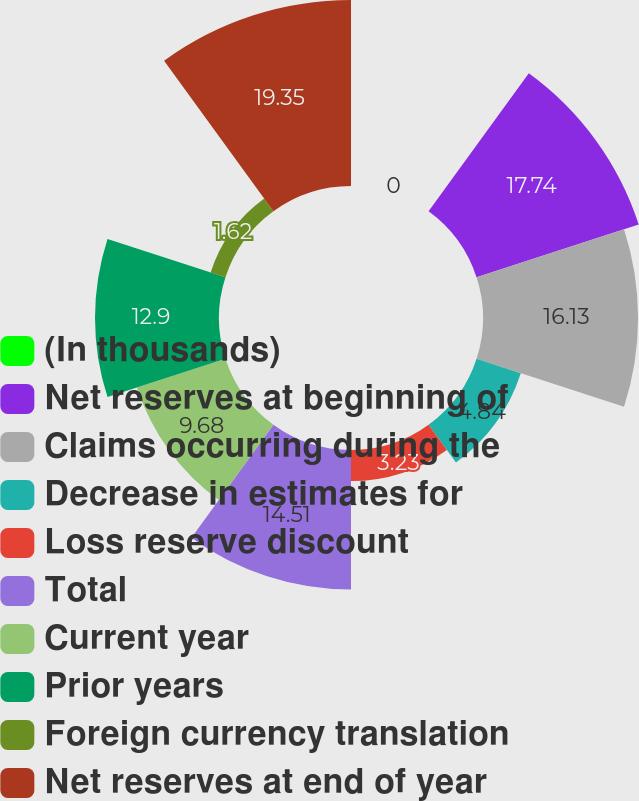<chart> <loc_0><loc_0><loc_500><loc_500><pie_chart><fcel>(In thousands)<fcel>Net reserves at beginning of<fcel>Claims occurring during the<fcel>Decrease in estimates for<fcel>Loss reserve discount<fcel>Total<fcel>Current year<fcel>Prior years<fcel>Foreign currency translation<fcel>Net reserves at end of year<nl><fcel>0.0%<fcel>17.74%<fcel>16.13%<fcel>4.84%<fcel>3.23%<fcel>14.51%<fcel>9.68%<fcel>12.9%<fcel>1.62%<fcel>19.35%<nl></chart> 